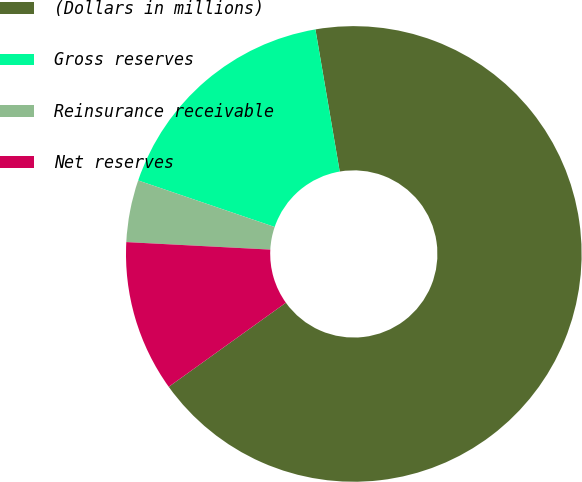<chart> <loc_0><loc_0><loc_500><loc_500><pie_chart><fcel>(Dollars in millions)<fcel>Gross reserves<fcel>Reinsurance receivable<fcel>Net reserves<nl><fcel>67.79%<fcel>17.08%<fcel>4.4%<fcel>10.74%<nl></chart> 